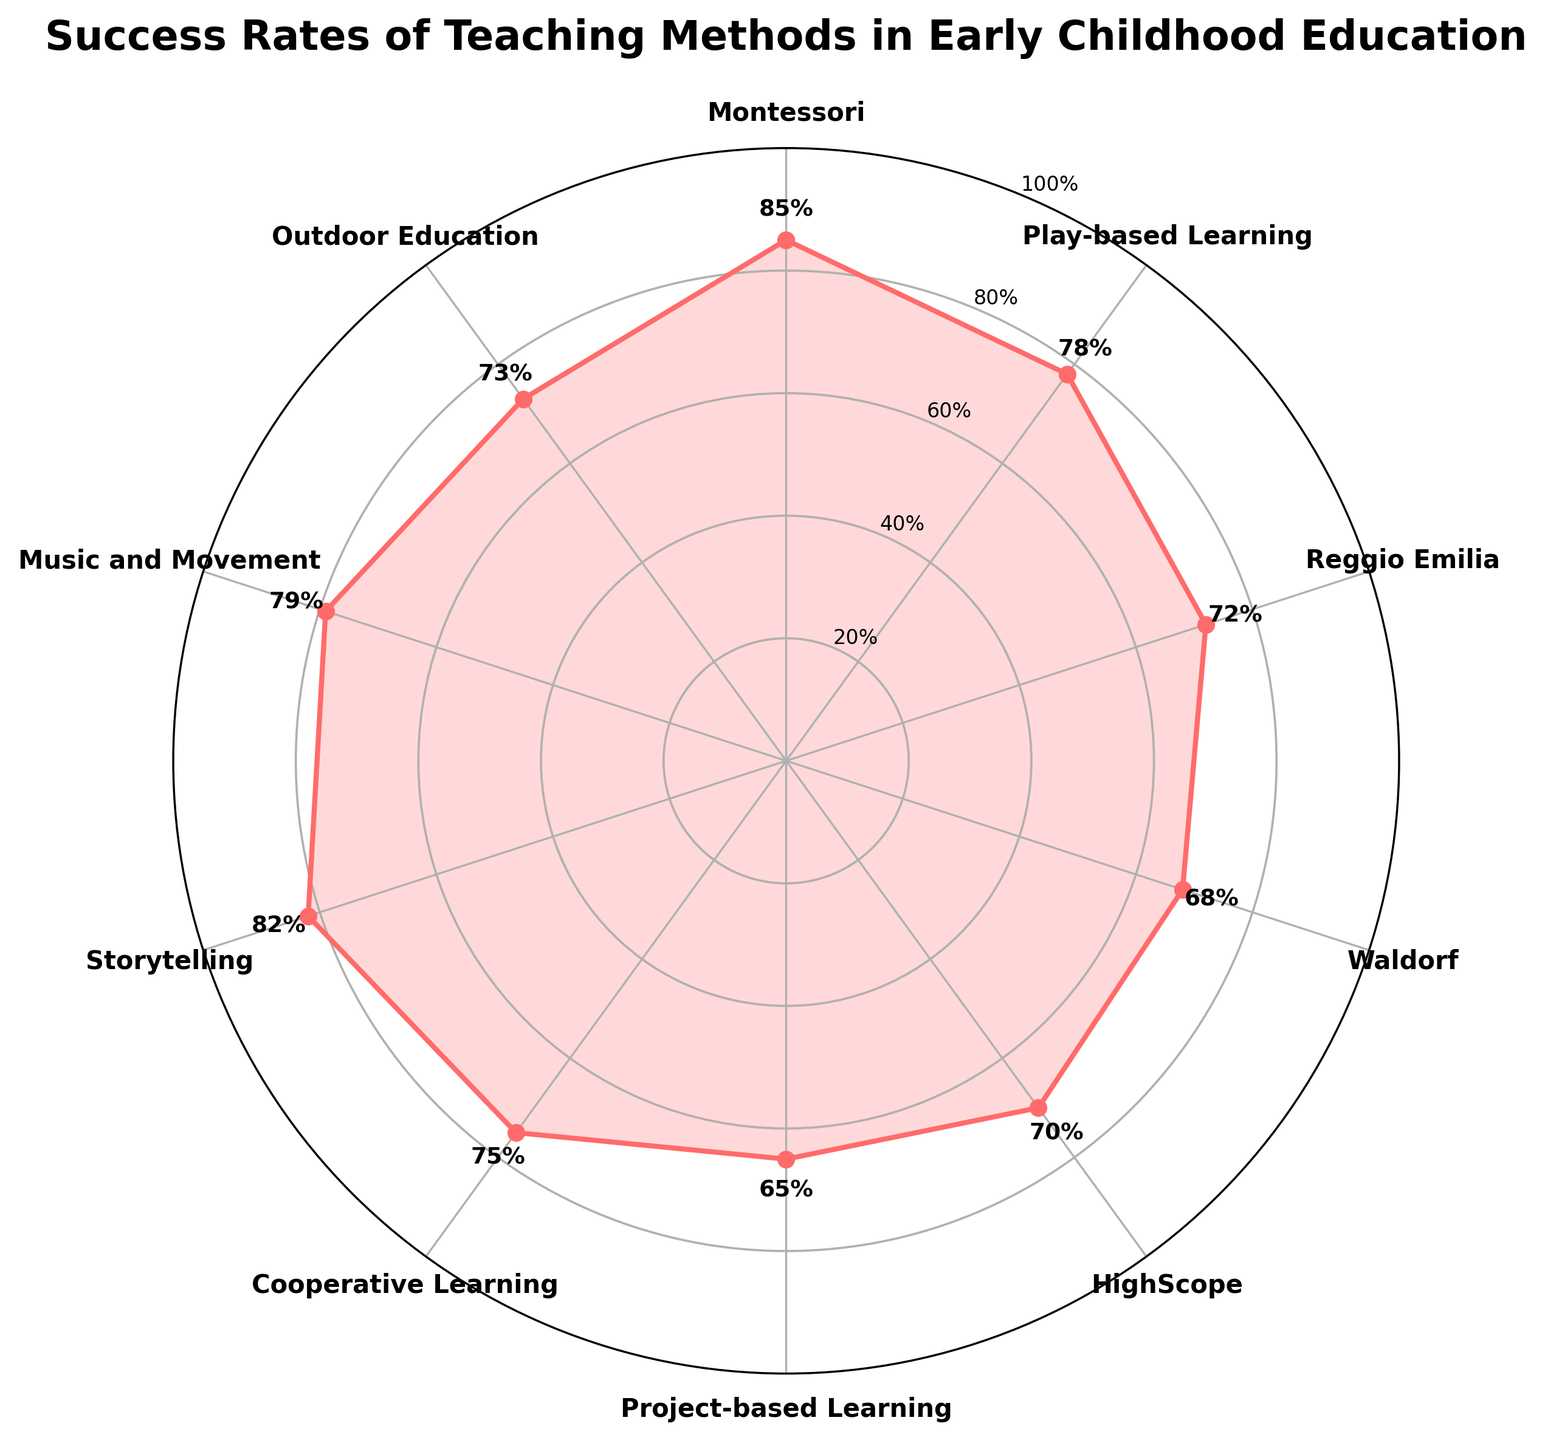What is the title of the plot? The title is clearly written at the top of the plot, which provides a general overview of the data being represented.
Answer: Success Rates of Teaching Methods in Early Childhood Education Which teaching method has the highest success rate? By looking at the radial plot, the method with the highest point on the success rate axis is the one with the maximum value.
Answer: Montessori How many teaching methods have a success rate above 75%? Identify all the data points on the plot with a success rate greater than 75% by checking the positions related to the percentage values on the radial axis.
Answer: 4 What is the success rate difference between Music and Movement and Waldorf? Find the success rates of Music and Movement (79%) and Waldorf (68%), then subtract the smaller value from the larger one.
Answer: 11% Which teaching method has a success rate closest to 70%? Identify the data points nearest to the 70% mark on the success rate axis.
Answer: HighScope What percentage of methods have a success rate below 72%? Count the number of teaching methods with a rate below 72% and divide by the total number of methods, then multiply by 100.
Answer: 40% Are there any methods with a success rate exactly on the 20% circle? Check the plot if any data points align with the circle for the 20% value.
Answer: No Which teaching method has the second highest success rate? Identify the data points with success rates in descending order and find the one in the second position.
Answer: Storytelling Is the success rate of Project-based Learning greater than that of Waldorf? Compare the success rates of Project-based Learning (65%) and Waldorf (68%).
Answer: No What is the average success rate of all the methods? Add up all the success rates and divide by the number of methods. (85 + 78 + 72 + 68 + 70 + 65 + 75 + 82 + 79 + 73) / 10 = 74.7%
Answer: 74.7% 